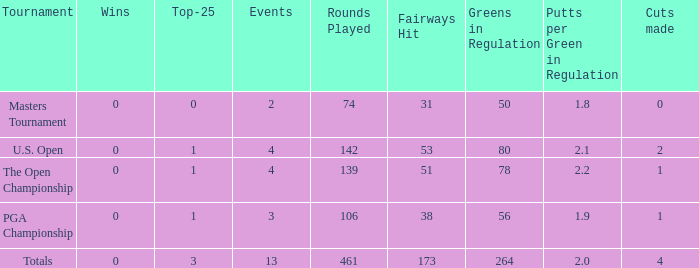How many cuts did he make in the tournament with 3 top 25s and under 13 events? None. Could you help me parse every detail presented in this table? {'header': ['Tournament', 'Wins', 'Top-25', 'Events', 'Rounds Played', 'Fairways Hit', 'Greens in Regulation', 'Putts per Green in Regulation', 'Cuts made'], 'rows': [['Masters Tournament', '0', '0', '2', '74', '31', '50', '1.8', '0'], ['U.S. Open', '0', '1', '4', '142', '53', '80', '2.1', '2'], ['The Open Championship', '0', '1', '4', '139', '51', '78', '2.2', '1'], ['PGA Championship', '0', '1', '3', '106', '38', '56', '1.9', '1'], ['Totals', '0', '3', '13', '461', '173', '264', '2.0', '4']]} 